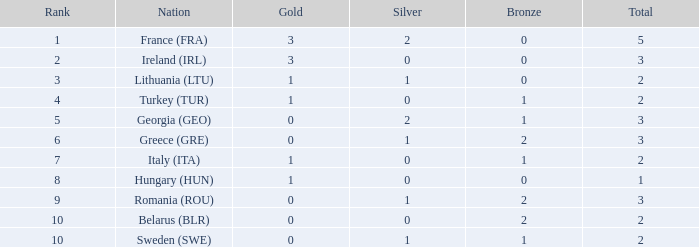Parse the full table. {'header': ['Rank', 'Nation', 'Gold', 'Silver', 'Bronze', 'Total'], 'rows': [['1', 'France (FRA)', '3', '2', '0', '5'], ['2', 'Ireland (IRL)', '3', '0', '0', '3'], ['3', 'Lithuania (LTU)', '1', '1', '0', '2'], ['4', 'Turkey (TUR)', '1', '0', '1', '2'], ['5', 'Georgia (GEO)', '0', '2', '1', '3'], ['6', 'Greece (GRE)', '0', '1', '2', '3'], ['7', 'Italy (ITA)', '1', '0', '1', '2'], ['8', 'Hungary (HUN)', '1', '0', '0', '1'], ['9', 'Romania (ROU)', '0', '1', '2', '3'], ['10', 'Belarus (BLR)', '0', '0', '2', '2'], ['10', 'Sweden (SWE)', '0', '1', '1', '2']]} How many instances are there of sweden (swe) possessing less than 1 silver? None. 